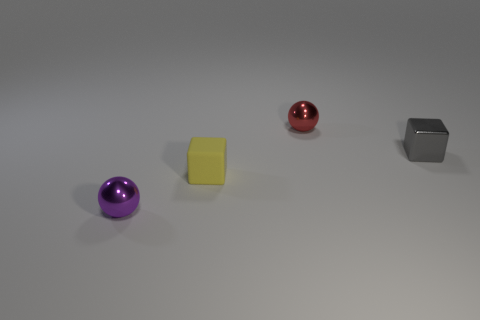Add 3 small purple shiny spheres. How many objects exist? 7 Add 1 gray balls. How many gray balls exist? 1 Subtract all red spheres. How many spheres are left? 1 Subtract 0 purple cubes. How many objects are left? 4 Subtract all cyan spheres. Subtract all red cylinders. How many spheres are left? 2 Subtract all tiny green things. Subtract all small yellow rubber blocks. How many objects are left? 3 Add 1 purple metal things. How many purple metal things are left? 2 